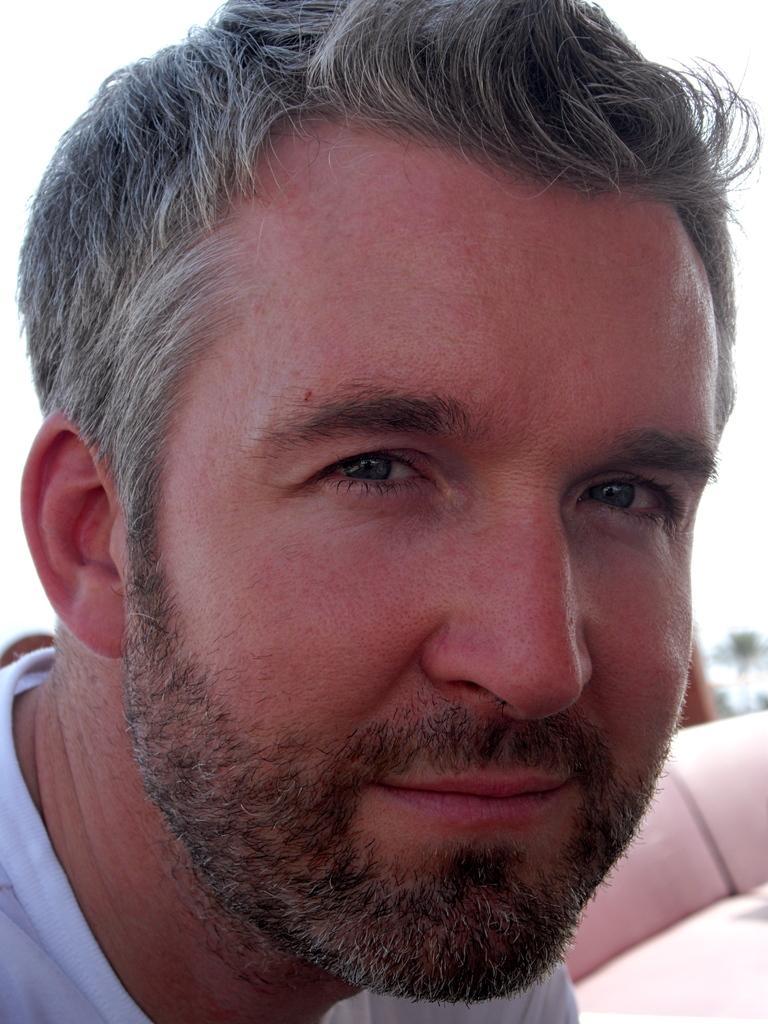How would you summarize this image in a sentence or two? In this image we can see the face of a person. 